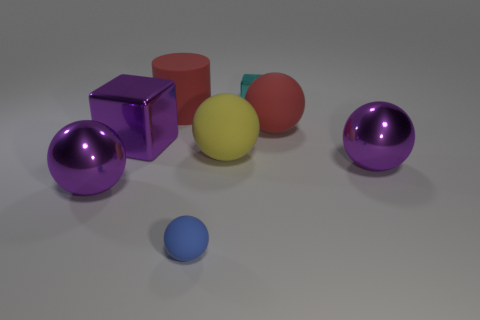Is the purple sphere that is to the right of the red cylinder made of the same material as the small thing that is in front of the big purple metal block?
Provide a succinct answer. No. What size is the yellow sphere?
Your answer should be very brief. Large. There is a yellow matte object that is the same shape as the blue thing; what size is it?
Provide a short and direct response. Large. How many blue balls are in front of the yellow matte ball?
Keep it short and to the point. 1. What is the color of the large metal sphere on the right side of the big purple object that is left of the large block?
Keep it short and to the point. Purple. Are there the same number of yellow objects right of the cyan metal thing and small cyan things that are to the right of the big yellow ball?
Your answer should be compact. No. How many blocks are either tiny things or matte things?
Your answer should be very brief. 1. There is a big red matte object that is on the left side of the small cube; what is its shape?
Your answer should be very brief. Cylinder. What material is the purple ball in front of the metallic ball on the right side of the tiny blue thing?
Provide a short and direct response. Metal. Are there more big metallic things to the left of the big yellow matte thing than large brown matte spheres?
Your answer should be compact. Yes. 